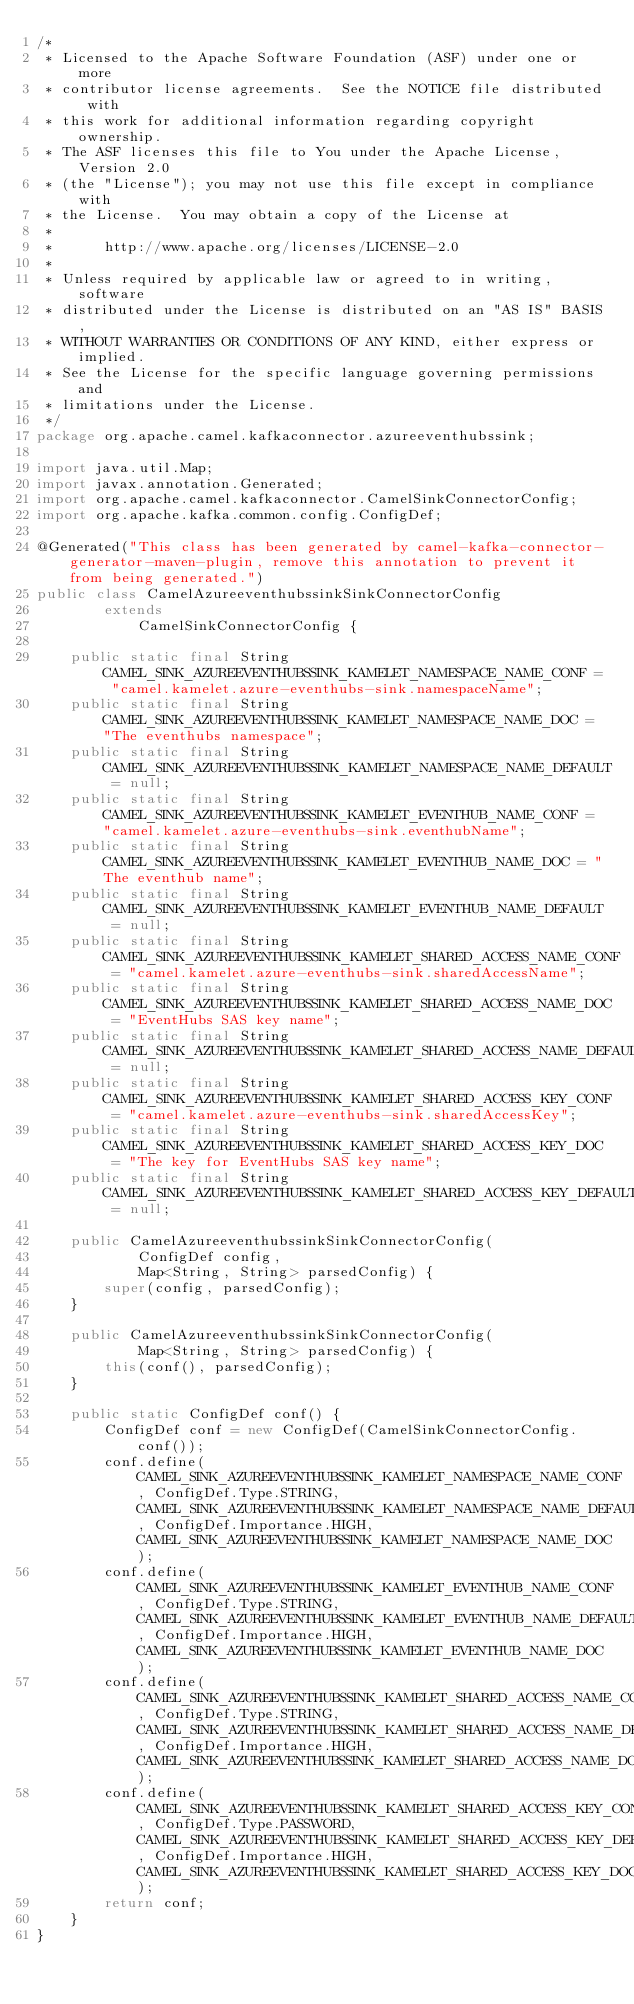Convert code to text. <code><loc_0><loc_0><loc_500><loc_500><_Java_>/*
 * Licensed to the Apache Software Foundation (ASF) under one or more
 * contributor license agreements.  See the NOTICE file distributed with
 * this work for additional information regarding copyright ownership.
 * The ASF licenses this file to You under the Apache License, Version 2.0
 * (the "License"); you may not use this file except in compliance with
 * the License.  You may obtain a copy of the License at
 *
 *      http://www.apache.org/licenses/LICENSE-2.0
 *
 * Unless required by applicable law or agreed to in writing, software
 * distributed under the License is distributed on an "AS IS" BASIS,
 * WITHOUT WARRANTIES OR CONDITIONS OF ANY KIND, either express or implied.
 * See the License for the specific language governing permissions and
 * limitations under the License.
 */
package org.apache.camel.kafkaconnector.azureeventhubssink;

import java.util.Map;
import javax.annotation.Generated;
import org.apache.camel.kafkaconnector.CamelSinkConnectorConfig;
import org.apache.kafka.common.config.ConfigDef;

@Generated("This class has been generated by camel-kafka-connector-generator-maven-plugin, remove this annotation to prevent it from being generated.")
public class CamelAzureeventhubssinkSinkConnectorConfig
        extends
            CamelSinkConnectorConfig {

    public static final String CAMEL_SINK_AZUREEVENTHUBSSINK_KAMELET_NAMESPACE_NAME_CONF = "camel.kamelet.azure-eventhubs-sink.namespaceName";
    public static final String CAMEL_SINK_AZUREEVENTHUBSSINK_KAMELET_NAMESPACE_NAME_DOC = "The eventhubs namespace";
    public static final String CAMEL_SINK_AZUREEVENTHUBSSINK_KAMELET_NAMESPACE_NAME_DEFAULT = null;
    public static final String CAMEL_SINK_AZUREEVENTHUBSSINK_KAMELET_EVENTHUB_NAME_CONF = "camel.kamelet.azure-eventhubs-sink.eventhubName";
    public static final String CAMEL_SINK_AZUREEVENTHUBSSINK_KAMELET_EVENTHUB_NAME_DOC = "The eventhub name";
    public static final String CAMEL_SINK_AZUREEVENTHUBSSINK_KAMELET_EVENTHUB_NAME_DEFAULT = null;
    public static final String CAMEL_SINK_AZUREEVENTHUBSSINK_KAMELET_SHARED_ACCESS_NAME_CONF = "camel.kamelet.azure-eventhubs-sink.sharedAccessName";
    public static final String CAMEL_SINK_AZUREEVENTHUBSSINK_KAMELET_SHARED_ACCESS_NAME_DOC = "EventHubs SAS key name";
    public static final String CAMEL_SINK_AZUREEVENTHUBSSINK_KAMELET_SHARED_ACCESS_NAME_DEFAULT = null;
    public static final String CAMEL_SINK_AZUREEVENTHUBSSINK_KAMELET_SHARED_ACCESS_KEY_CONF = "camel.kamelet.azure-eventhubs-sink.sharedAccessKey";
    public static final String CAMEL_SINK_AZUREEVENTHUBSSINK_KAMELET_SHARED_ACCESS_KEY_DOC = "The key for EventHubs SAS key name";
    public static final String CAMEL_SINK_AZUREEVENTHUBSSINK_KAMELET_SHARED_ACCESS_KEY_DEFAULT = null;

    public CamelAzureeventhubssinkSinkConnectorConfig(
            ConfigDef config,
            Map<String, String> parsedConfig) {
        super(config, parsedConfig);
    }

    public CamelAzureeventhubssinkSinkConnectorConfig(
            Map<String, String> parsedConfig) {
        this(conf(), parsedConfig);
    }

    public static ConfigDef conf() {
        ConfigDef conf = new ConfigDef(CamelSinkConnectorConfig.conf());
        conf.define(CAMEL_SINK_AZUREEVENTHUBSSINK_KAMELET_NAMESPACE_NAME_CONF, ConfigDef.Type.STRING, CAMEL_SINK_AZUREEVENTHUBSSINK_KAMELET_NAMESPACE_NAME_DEFAULT, ConfigDef.Importance.HIGH, CAMEL_SINK_AZUREEVENTHUBSSINK_KAMELET_NAMESPACE_NAME_DOC);
        conf.define(CAMEL_SINK_AZUREEVENTHUBSSINK_KAMELET_EVENTHUB_NAME_CONF, ConfigDef.Type.STRING, CAMEL_SINK_AZUREEVENTHUBSSINK_KAMELET_EVENTHUB_NAME_DEFAULT, ConfigDef.Importance.HIGH, CAMEL_SINK_AZUREEVENTHUBSSINK_KAMELET_EVENTHUB_NAME_DOC);
        conf.define(CAMEL_SINK_AZUREEVENTHUBSSINK_KAMELET_SHARED_ACCESS_NAME_CONF, ConfigDef.Type.STRING, CAMEL_SINK_AZUREEVENTHUBSSINK_KAMELET_SHARED_ACCESS_NAME_DEFAULT, ConfigDef.Importance.HIGH, CAMEL_SINK_AZUREEVENTHUBSSINK_KAMELET_SHARED_ACCESS_NAME_DOC);
        conf.define(CAMEL_SINK_AZUREEVENTHUBSSINK_KAMELET_SHARED_ACCESS_KEY_CONF, ConfigDef.Type.PASSWORD, CAMEL_SINK_AZUREEVENTHUBSSINK_KAMELET_SHARED_ACCESS_KEY_DEFAULT, ConfigDef.Importance.HIGH, CAMEL_SINK_AZUREEVENTHUBSSINK_KAMELET_SHARED_ACCESS_KEY_DOC);
        return conf;
    }
}</code> 